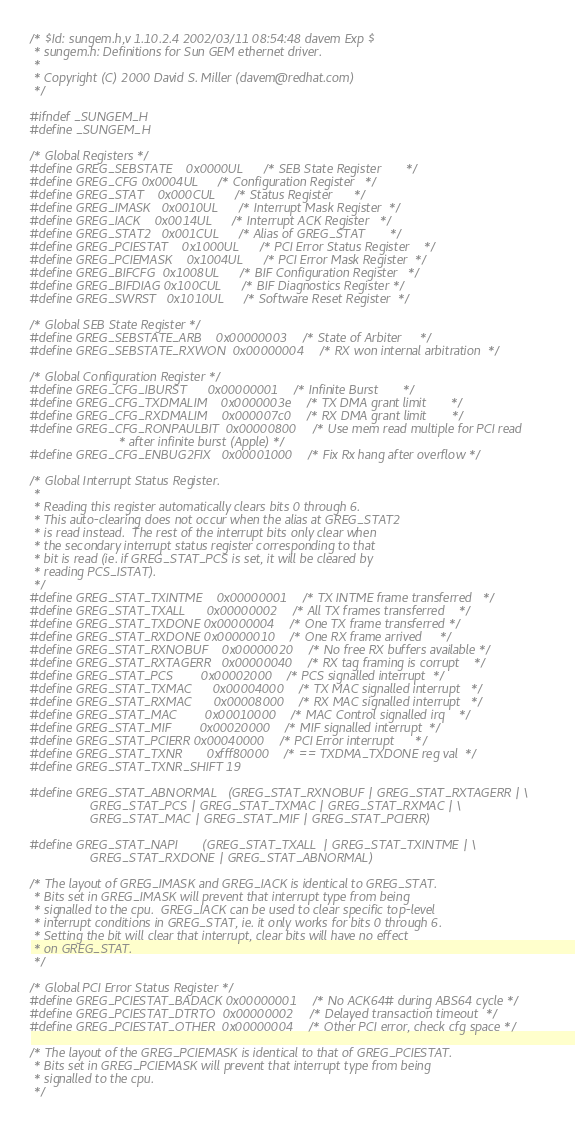Convert code to text. <code><loc_0><loc_0><loc_500><loc_500><_C_>/* $Id: sungem.h,v 1.10.2.4 2002/03/11 08:54:48 davem Exp $
 * sungem.h: Definitions for Sun GEM ethernet driver.
 *
 * Copyright (C) 2000 David S. Miller (davem@redhat.com)
 */

#ifndef _SUNGEM_H
#define _SUNGEM_H

/* Global Registers */
#define GREG_SEBSTATE	0x0000UL	/* SEB State Register		*/
#define GREG_CFG	0x0004UL	/* Configuration Register	*/
#define GREG_STAT	0x000CUL	/* Status Register		*/
#define GREG_IMASK	0x0010UL	/* Interrupt Mask Register	*/
#define GREG_IACK	0x0014UL	/* Interrupt ACK Register	*/
#define GREG_STAT2	0x001CUL	/* Alias of GREG_STAT		*/
#define GREG_PCIESTAT	0x1000UL	/* PCI Error Status Register	*/
#define GREG_PCIEMASK	0x1004UL	/* PCI Error Mask Register	*/
#define GREG_BIFCFG	0x1008UL	/* BIF Configuration Register	*/
#define GREG_BIFDIAG	0x100CUL	/* BIF Diagnostics Register	*/
#define GREG_SWRST	0x1010UL	/* Software Reset Register	*/

/* Global SEB State Register */
#define GREG_SEBSTATE_ARB	0x00000003	/* State of Arbiter		*/
#define GREG_SEBSTATE_RXWON	0x00000004	/* RX won internal arbitration	*/

/* Global Configuration Register */
#define GREG_CFG_IBURST		0x00000001	/* Infinite Burst		*/
#define GREG_CFG_TXDMALIM	0x0000003e	/* TX DMA grant limit		*/
#define GREG_CFG_RXDMALIM	0x000007c0	/* RX DMA grant limit		*/
#define GREG_CFG_RONPAULBIT	0x00000800	/* Use mem read multiple for PCI read
						 * after infinite burst (Apple) */
#define GREG_CFG_ENBUG2FIX	0x00001000	/* Fix Rx hang after overflow */

/* Global Interrupt Status Register.
 *
 * Reading this register automatically clears bits 0 through 6.
 * This auto-clearing does not occur when the alias at GREG_STAT2
 * is read instead.  The rest of the interrupt bits only clear when
 * the secondary interrupt status register corresponding to that
 * bit is read (ie. if GREG_STAT_PCS is set, it will be cleared by
 * reading PCS_ISTAT).
 */
#define GREG_STAT_TXINTME	0x00000001	/* TX INTME frame transferred	*/
#define GREG_STAT_TXALL		0x00000002	/* All TX frames transferred	*/
#define GREG_STAT_TXDONE	0x00000004	/* One TX frame transferred	*/
#define GREG_STAT_RXDONE	0x00000010	/* One RX frame arrived		*/
#define GREG_STAT_RXNOBUF	0x00000020	/* No free RX buffers available	*/
#define GREG_STAT_RXTAGERR	0x00000040	/* RX tag framing is corrupt	*/
#define GREG_STAT_PCS		0x00002000	/* PCS signalled interrupt	*/
#define GREG_STAT_TXMAC		0x00004000	/* TX MAC signalled interrupt	*/
#define GREG_STAT_RXMAC		0x00008000	/* RX MAC signalled interrupt	*/
#define GREG_STAT_MAC		0x00010000	/* MAC Control signalled irq	*/
#define GREG_STAT_MIF		0x00020000	/* MIF signalled interrupt	*/
#define GREG_STAT_PCIERR	0x00040000	/* PCI Error interrupt		*/
#define GREG_STAT_TXNR		0xfff80000	/* == TXDMA_TXDONE reg val	*/
#define GREG_STAT_TXNR_SHIFT	19

#define GREG_STAT_ABNORMAL	(GREG_STAT_RXNOBUF | GREG_STAT_RXTAGERR | \
				 GREG_STAT_PCS | GREG_STAT_TXMAC | GREG_STAT_RXMAC | \
				 GREG_STAT_MAC | GREG_STAT_MIF | GREG_STAT_PCIERR)

#define GREG_STAT_NAPI		(GREG_STAT_TXALL  | GREG_STAT_TXINTME | \
				 GREG_STAT_RXDONE | GREG_STAT_ABNORMAL)

/* The layout of GREG_IMASK and GREG_IACK is identical to GREG_STAT.
 * Bits set in GREG_IMASK will prevent that interrupt type from being
 * signalled to the cpu.  GREG_IACK can be used to clear specific top-level
 * interrupt conditions in GREG_STAT, ie. it only works for bits 0 through 6.
 * Setting the bit will clear that interrupt, clear bits will have no effect
 * on GREG_STAT.
 */

/* Global PCI Error Status Register */
#define GREG_PCIESTAT_BADACK	0x00000001	/* No ACK64# during ABS64 cycle	*/
#define GREG_PCIESTAT_DTRTO	0x00000002	/* Delayed transaction timeout	*/
#define GREG_PCIESTAT_OTHER	0x00000004	/* Other PCI error, check cfg space */

/* The layout of the GREG_PCIEMASK is identical to that of GREG_PCIESTAT.
 * Bits set in GREG_PCIEMASK will prevent that interrupt type from being
 * signalled to the cpu.
 */
</code> 